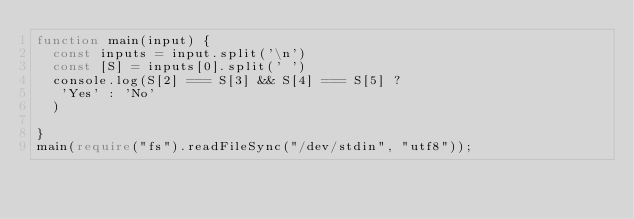<code> <loc_0><loc_0><loc_500><loc_500><_TypeScript_>function main(input) {
  const inputs = input.split('\n')
  const [S] = inputs[0].split(' ')
  console.log(S[2] === S[3] && S[4] === S[5] ?
   'Yes' : 'No'
  )

}
main(require("fs").readFileSync("/dev/stdin", "utf8"));

</code> 